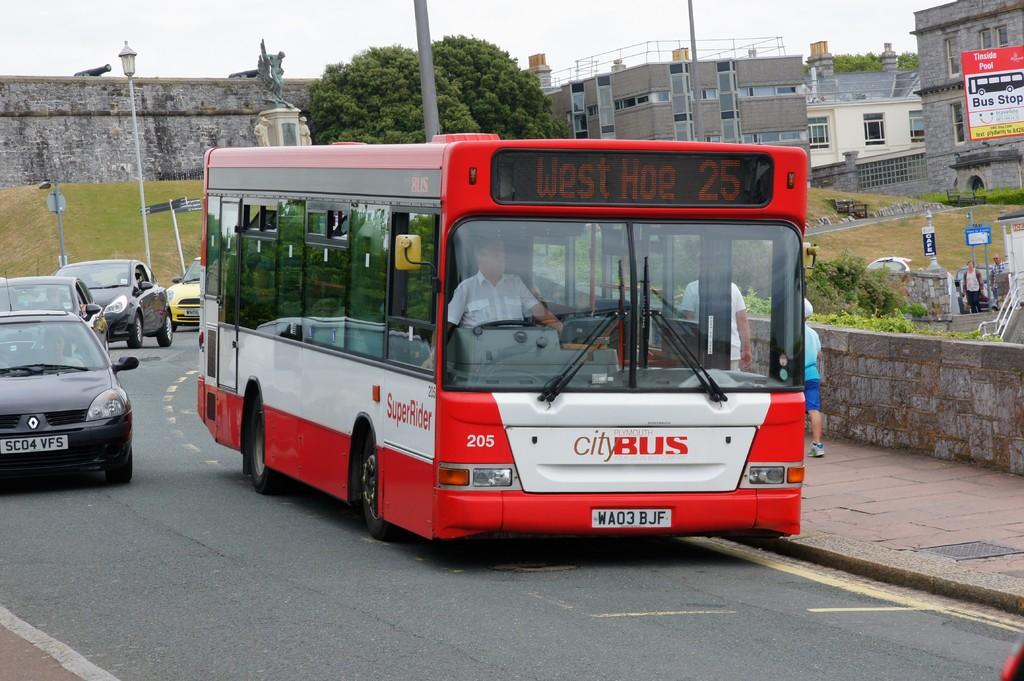What bus route is this bus on?
Ensure brevity in your answer.  West hoe 25. Is this the city bus?
Your answer should be compact. Yes. 